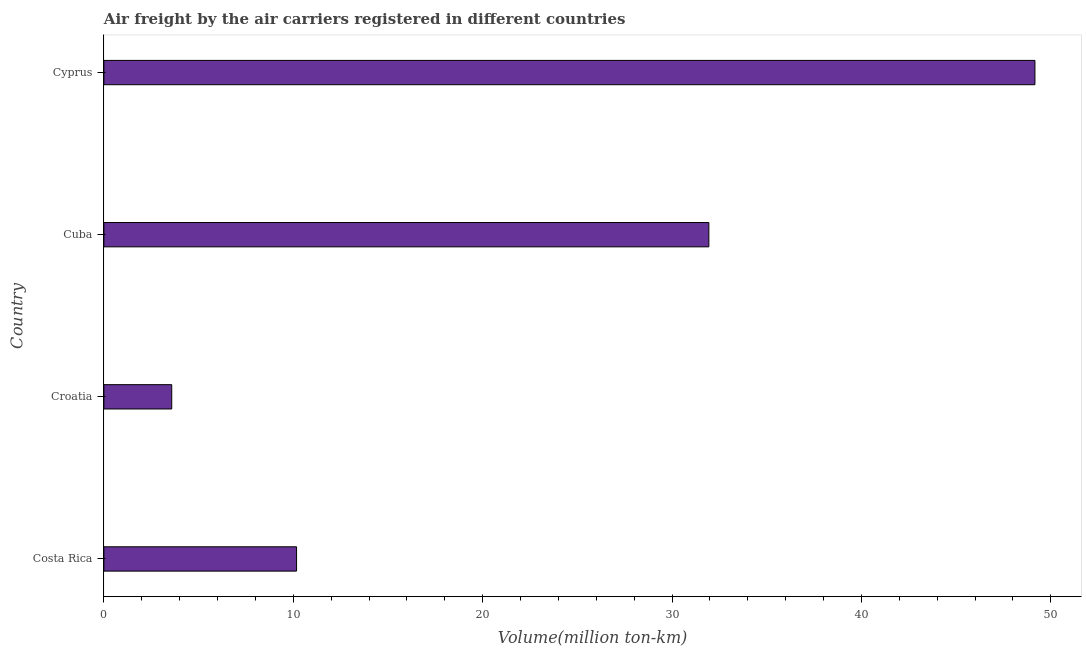What is the title of the graph?
Offer a terse response. Air freight by the air carriers registered in different countries. What is the label or title of the X-axis?
Give a very brief answer. Volume(million ton-km). What is the label or title of the Y-axis?
Your answer should be compact. Country. What is the air freight in Cyprus?
Your answer should be compact. 49.16. Across all countries, what is the maximum air freight?
Keep it short and to the point. 49.16. Across all countries, what is the minimum air freight?
Provide a short and direct response. 3.58. In which country was the air freight maximum?
Make the answer very short. Cyprus. In which country was the air freight minimum?
Keep it short and to the point. Croatia. What is the sum of the air freight?
Your answer should be compact. 94.86. What is the difference between the air freight in Croatia and Cyprus?
Provide a short and direct response. -45.58. What is the average air freight per country?
Provide a succinct answer. 23.71. What is the median air freight?
Offer a terse response. 21.06. What is the ratio of the air freight in Croatia to that in Cuba?
Provide a succinct answer. 0.11. Is the air freight in Costa Rica less than that in Cuba?
Keep it short and to the point. Yes. What is the difference between the highest and the second highest air freight?
Keep it short and to the point. 17.22. Is the sum of the air freight in Croatia and Cuba greater than the maximum air freight across all countries?
Keep it short and to the point. No. What is the difference between the highest and the lowest air freight?
Give a very brief answer. 45.58. In how many countries, is the air freight greater than the average air freight taken over all countries?
Your answer should be very brief. 2. How many countries are there in the graph?
Give a very brief answer. 4. What is the Volume(million ton-km) in Costa Rica?
Make the answer very short. 10.17. What is the Volume(million ton-km) of Croatia?
Give a very brief answer. 3.58. What is the Volume(million ton-km) of Cuba?
Your response must be concise. 31.94. What is the Volume(million ton-km) in Cyprus?
Keep it short and to the point. 49.16. What is the difference between the Volume(million ton-km) in Costa Rica and Croatia?
Your answer should be very brief. 6.59. What is the difference between the Volume(million ton-km) in Costa Rica and Cuba?
Ensure brevity in your answer.  -21.77. What is the difference between the Volume(million ton-km) in Costa Rica and Cyprus?
Provide a short and direct response. -38.99. What is the difference between the Volume(million ton-km) in Croatia and Cuba?
Your answer should be compact. -28.36. What is the difference between the Volume(million ton-km) in Croatia and Cyprus?
Keep it short and to the point. -45.58. What is the difference between the Volume(million ton-km) in Cuba and Cyprus?
Your response must be concise. -17.22. What is the ratio of the Volume(million ton-km) in Costa Rica to that in Croatia?
Your response must be concise. 2.84. What is the ratio of the Volume(million ton-km) in Costa Rica to that in Cuba?
Provide a short and direct response. 0.32. What is the ratio of the Volume(million ton-km) in Costa Rica to that in Cyprus?
Ensure brevity in your answer.  0.21. What is the ratio of the Volume(million ton-km) in Croatia to that in Cuba?
Provide a short and direct response. 0.11. What is the ratio of the Volume(million ton-km) in Croatia to that in Cyprus?
Offer a very short reply. 0.07. What is the ratio of the Volume(million ton-km) in Cuba to that in Cyprus?
Provide a short and direct response. 0.65. 